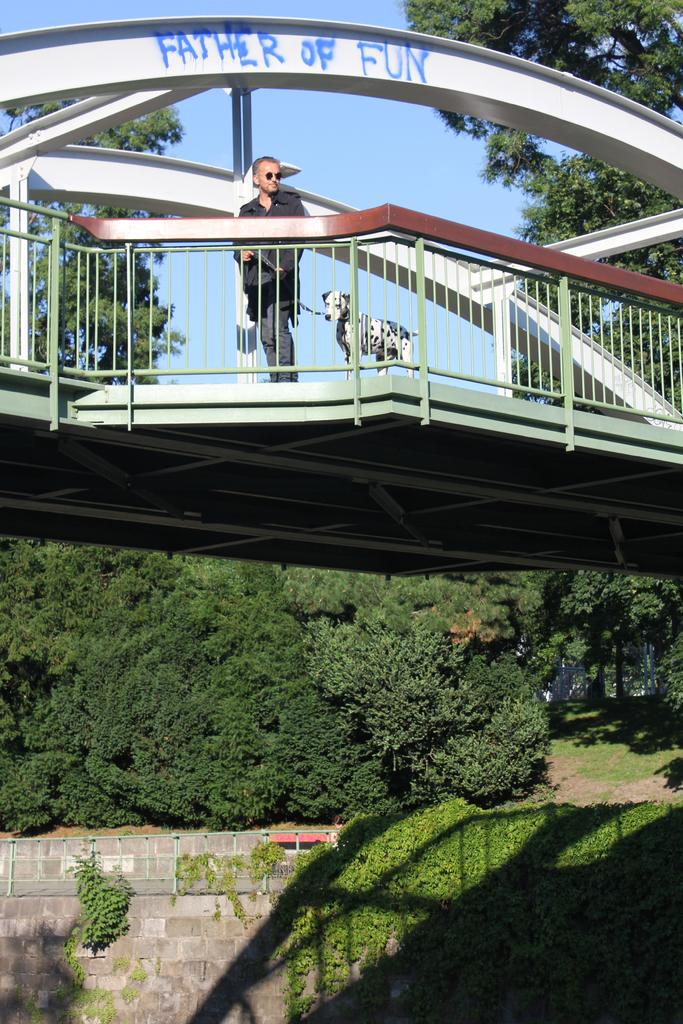What is the man in the image doing? The man is standing on a bridge in the image. Is there any other living creature with the man? Yes, there is a dog beside the man. What can be seen in the image besides the man and the dog? There is a fence, grass, a wall, trees, and the sky visible in the background. How many points does the family earn in the image? There is no reference to a family or points in the image, so it's not possible to answer that question. 